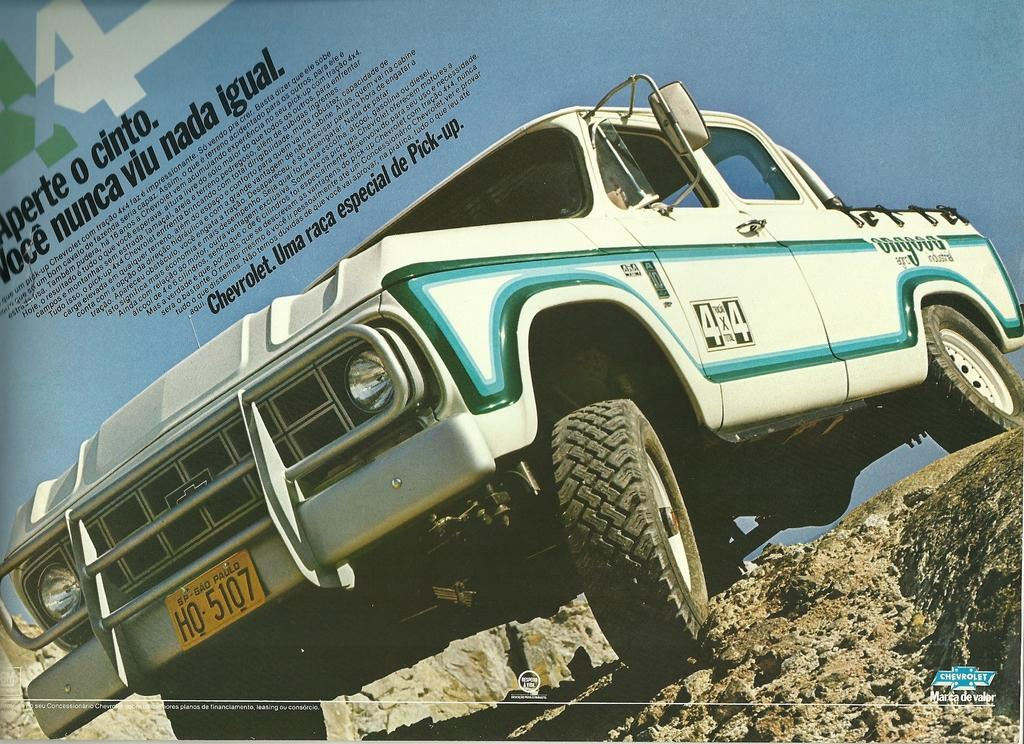What is the main subject of the image? The main subject of the image is a magazine photography. What type of vehicle is present in the image? There is a white color jeep in the image. Where is the jeep located in the image? The jeep is parked on a rock mountain in the image. Is there any text or quote on the photograph? Yes, there is a small quote on the photograph. Can you see any quicksand in the image? No, there is no quicksand present in the image. Is there a playground visible in the image? No, there is no playground visible in the image. 